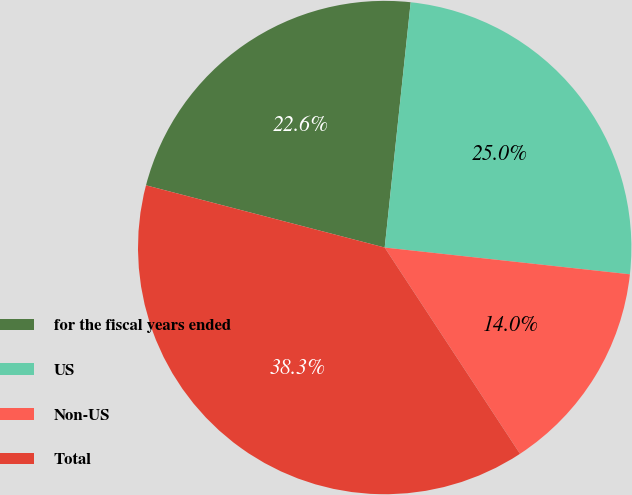Convert chart. <chart><loc_0><loc_0><loc_500><loc_500><pie_chart><fcel>for the fiscal years ended<fcel>US<fcel>Non-US<fcel>Total<nl><fcel>22.62%<fcel>25.05%<fcel>14.03%<fcel>38.3%<nl></chart> 